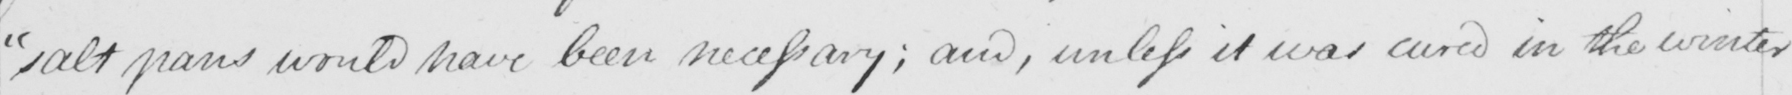What does this handwritten line say? salt pans would have been necessary ; and unless it was cured in the winter 